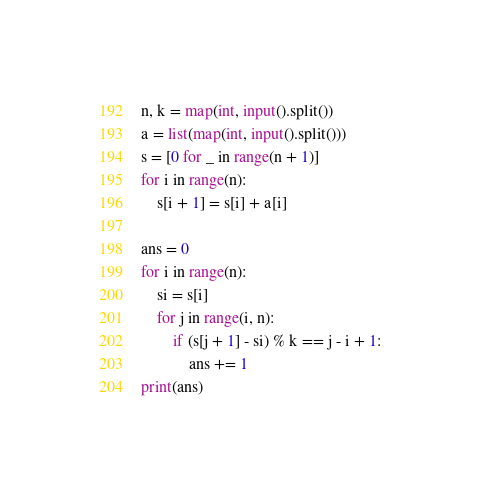<code> <loc_0><loc_0><loc_500><loc_500><_Python_>n, k = map(int, input().split())
a = list(map(int, input().split()))
s = [0 for _ in range(n + 1)]
for i in range(n):
    s[i + 1] = s[i] + a[i]

ans = 0
for i in range(n):
    si = s[i]
    for j in range(i, n):
        if (s[j + 1] - si) % k == j - i + 1:
            ans += 1
print(ans)
</code> 